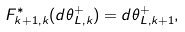<formula> <loc_0><loc_0><loc_500><loc_500>F _ { k + 1 , k } ^ { * } ( d \theta _ { L , k } ^ { + } ) = d \theta _ { L , k + 1 } ^ { + } ,</formula> 